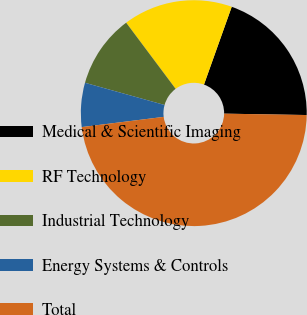Convert chart. <chart><loc_0><loc_0><loc_500><loc_500><pie_chart><fcel>Medical & Scientific Imaging<fcel>RF Technology<fcel>Industrial Technology<fcel>Energy Systems & Controls<fcel>Total<nl><fcel>19.81%<fcel>15.67%<fcel>10.45%<fcel>6.3%<fcel>47.76%<nl></chart> 